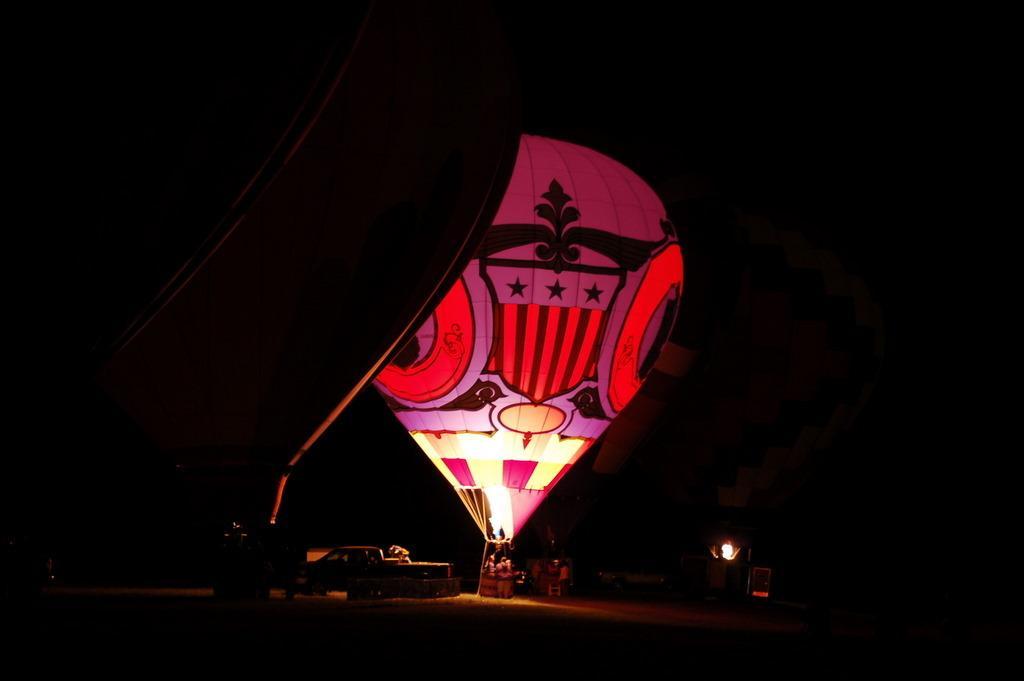Could you give a brief overview of what you see in this image? In this image we can see a car, two air balloons, light and people. The background is dark. 